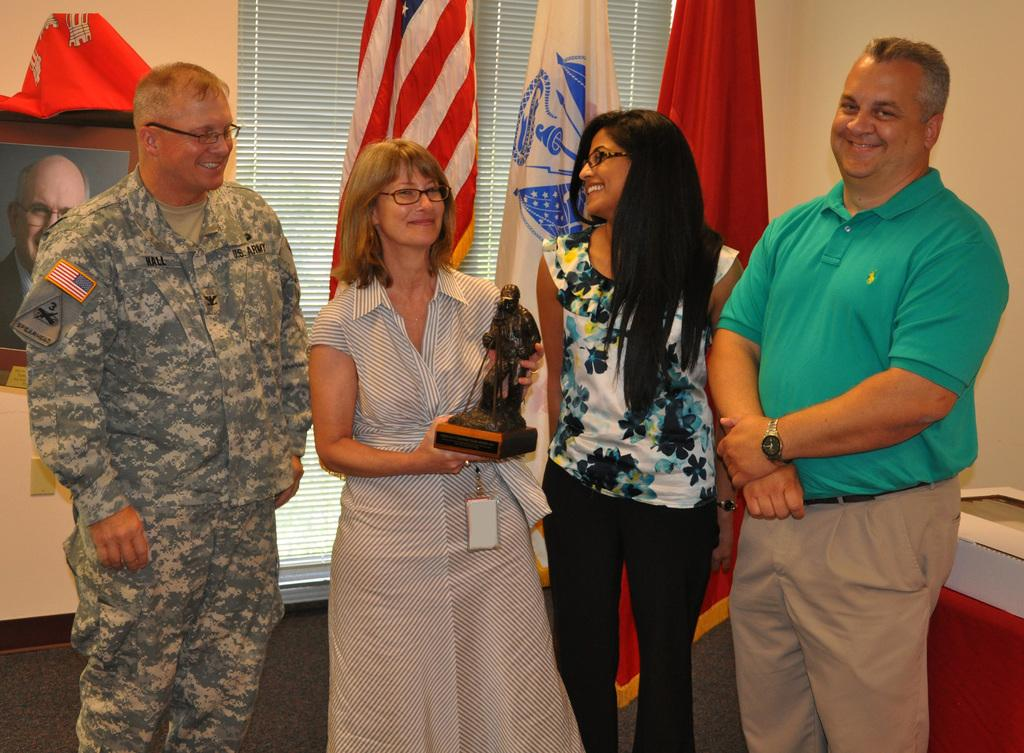What are the people in the image doing? The people in the image are standing. What is the person holding in the image? The person is holding a statue. What can be seen in the background of the image? There are flags and a wall in the background of the image. What type of steam is coming out of the statue in the image? There is no steam coming out of the statue in the image, as it is a statue and not a source of steam. 